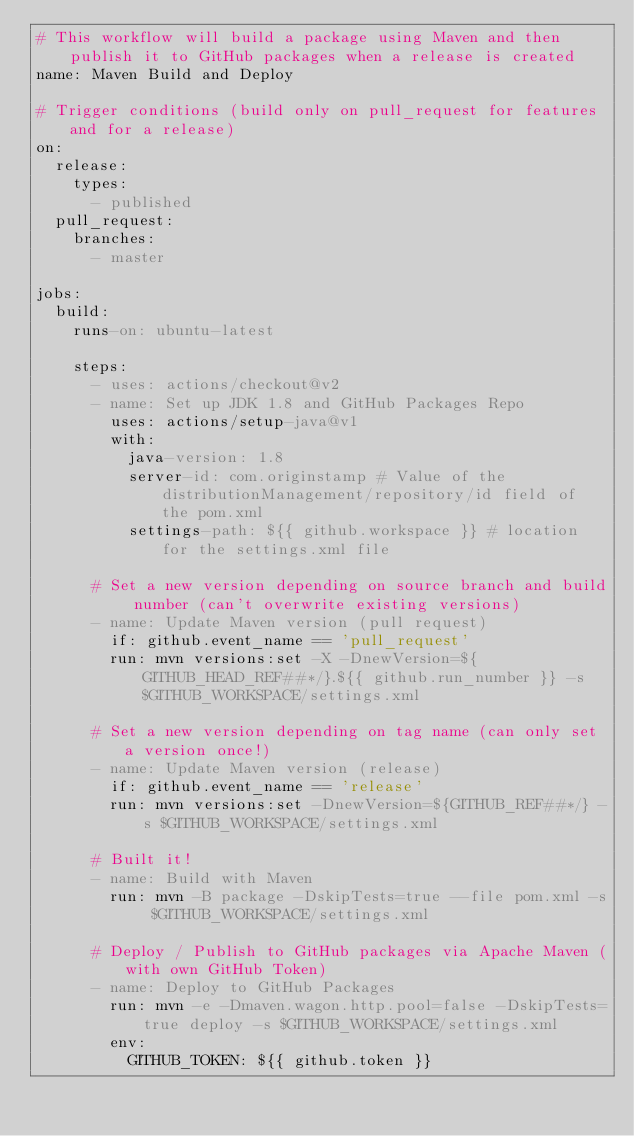<code> <loc_0><loc_0><loc_500><loc_500><_YAML_># This workflow will build a package using Maven and then publish it to GitHub packages when a release is created
name: Maven Build and Deploy

# Trigger conditions (build only on pull_request for features and for a release)
on:
  release:
    types:
      - published
  pull_request:
    branches:
      - master

jobs:
  build:
    runs-on: ubuntu-latest

    steps:
      - uses: actions/checkout@v2
      - name: Set up JDK 1.8 and GitHub Packages Repo
        uses: actions/setup-java@v1
        with:
          java-version: 1.8
          server-id: com.originstamp # Value of the distributionManagement/repository/id field of the pom.xml
          settings-path: ${{ github.workspace }} # location for the settings.xml file

      # Set a new version depending on source branch and build number (can't overwrite existing versions)
      - name: Update Maven version (pull request)
        if: github.event_name == 'pull_request'
        run: mvn versions:set -X -DnewVersion=${GITHUB_HEAD_REF##*/}.${{ github.run_number }} -s $GITHUB_WORKSPACE/settings.xml

      # Set a new version depending on tag name (can only set a version once!)
      - name: Update Maven version (release)
        if: github.event_name == 'release'
        run: mvn versions:set -DnewVersion=${GITHUB_REF##*/} -s $GITHUB_WORKSPACE/settings.xml

      # Built it!
      - name: Build with Maven
        run: mvn -B package -DskipTests=true --file pom.xml -s $GITHUB_WORKSPACE/settings.xml

      # Deploy / Publish to GitHub packages via Apache Maven (with own GitHub Token)
      - name: Deploy to GitHub Packages
        run: mvn -e -Dmaven.wagon.http.pool=false -DskipTests=true deploy -s $GITHUB_WORKSPACE/settings.xml
        env:
          GITHUB_TOKEN: ${{ github.token }}
</code> 